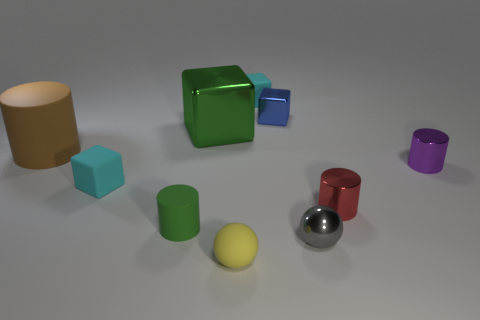There is a red object that is the same shape as the brown object; what is it made of?
Offer a very short reply. Metal. How many other red cylinders are the same size as the red cylinder?
Your response must be concise. 0. Do the brown matte thing and the blue metallic cube have the same size?
Give a very brief answer. No. There is a block that is both behind the green shiny block and to the left of the blue object; what size is it?
Give a very brief answer. Small. Are there more tiny shiny balls in front of the small gray object than purple cylinders that are to the left of the red metallic thing?
Provide a succinct answer. No. What color is the other tiny matte object that is the same shape as the brown object?
Give a very brief answer. Green. Do the rubber block that is in front of the tiny purple shiny cylinder and the large cylinder have the same color?
Keep it short and to the point. No. How many yellow cylinders are there?
Keep it short and to the point. 0. Is the material of the tiny block to the left of the yellow ball the same as the tiny blue cube?
Offer a terse response. No. How many brown matte things are to the right of the small cyan object behind the rubber cylinder that is behind the green rubber cylinder?
Provide a succinct answer. 0. 